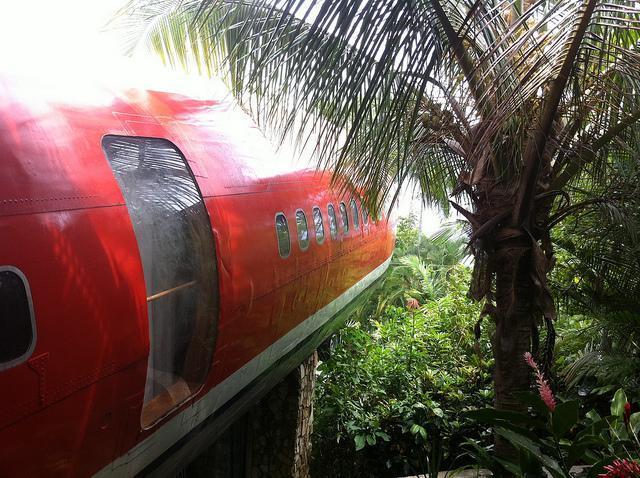How many bears are visible?
Give a very brief answer. 0. 